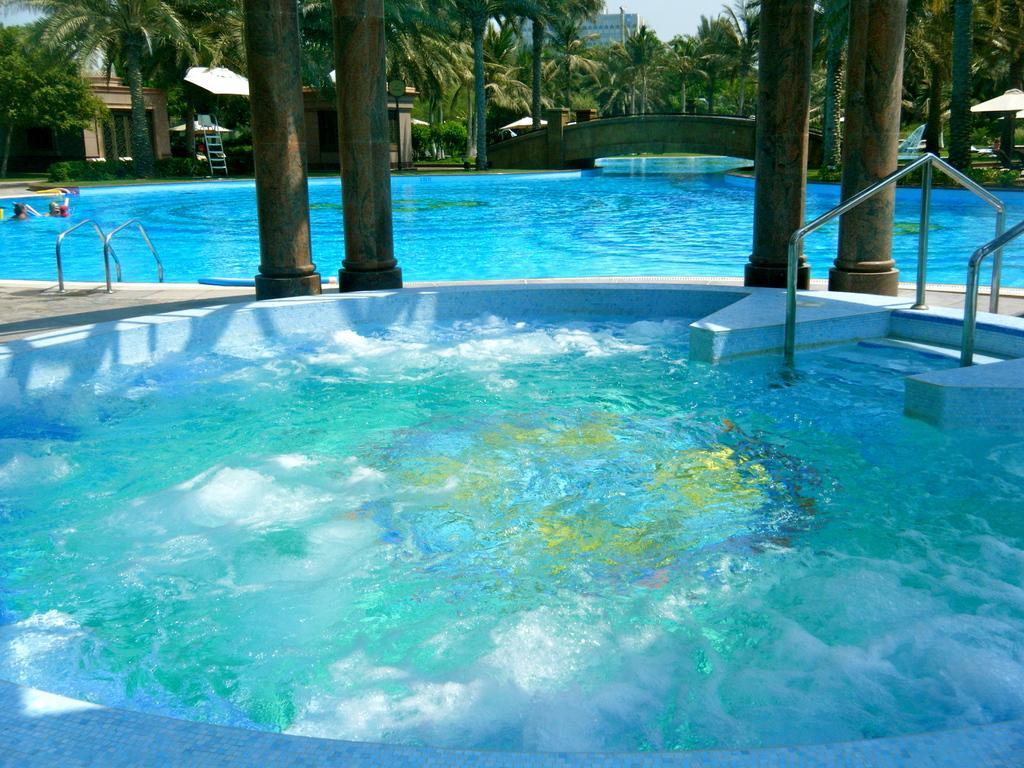Describe this image in one or two sentences. In this image there is the sky, there is a building, there is a pole, there is a board, there are trees, there is a swimming pool, there are persons in the swimming pool, there are pillars truncated, there are trees truncated towards the left of the image, there is an object truncated towards the right of the image, there are trees truncated towards the right of the image, there is a staircase. 